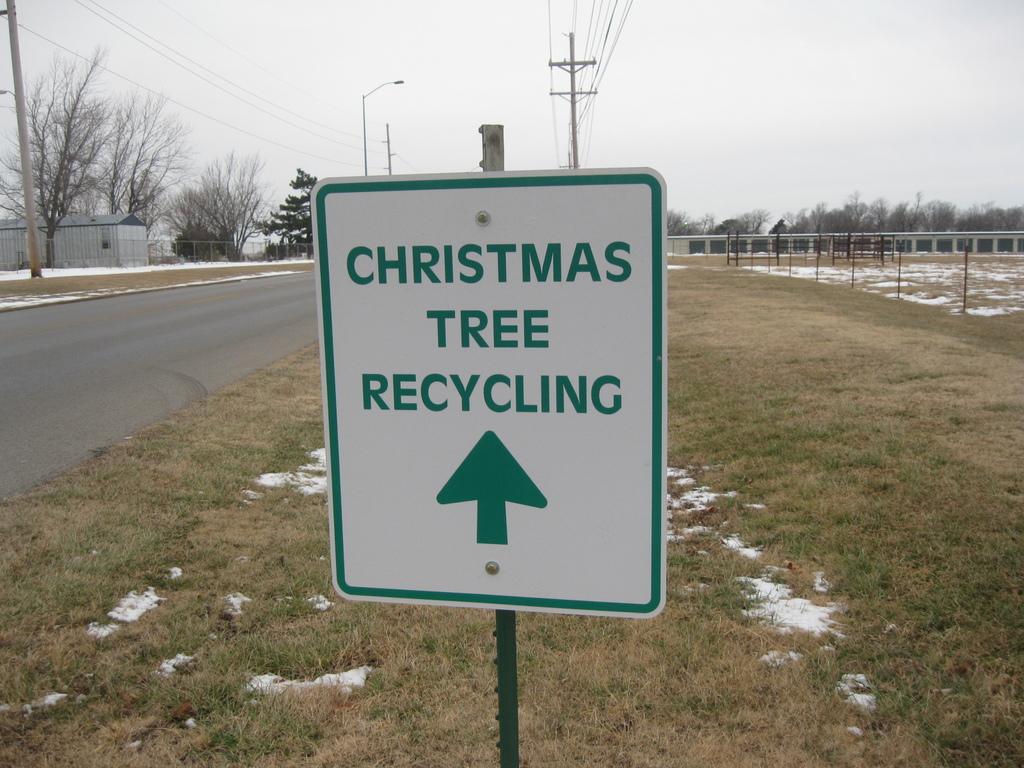What is the top word on the sign?
Keep it short and to the point. Christmas. 